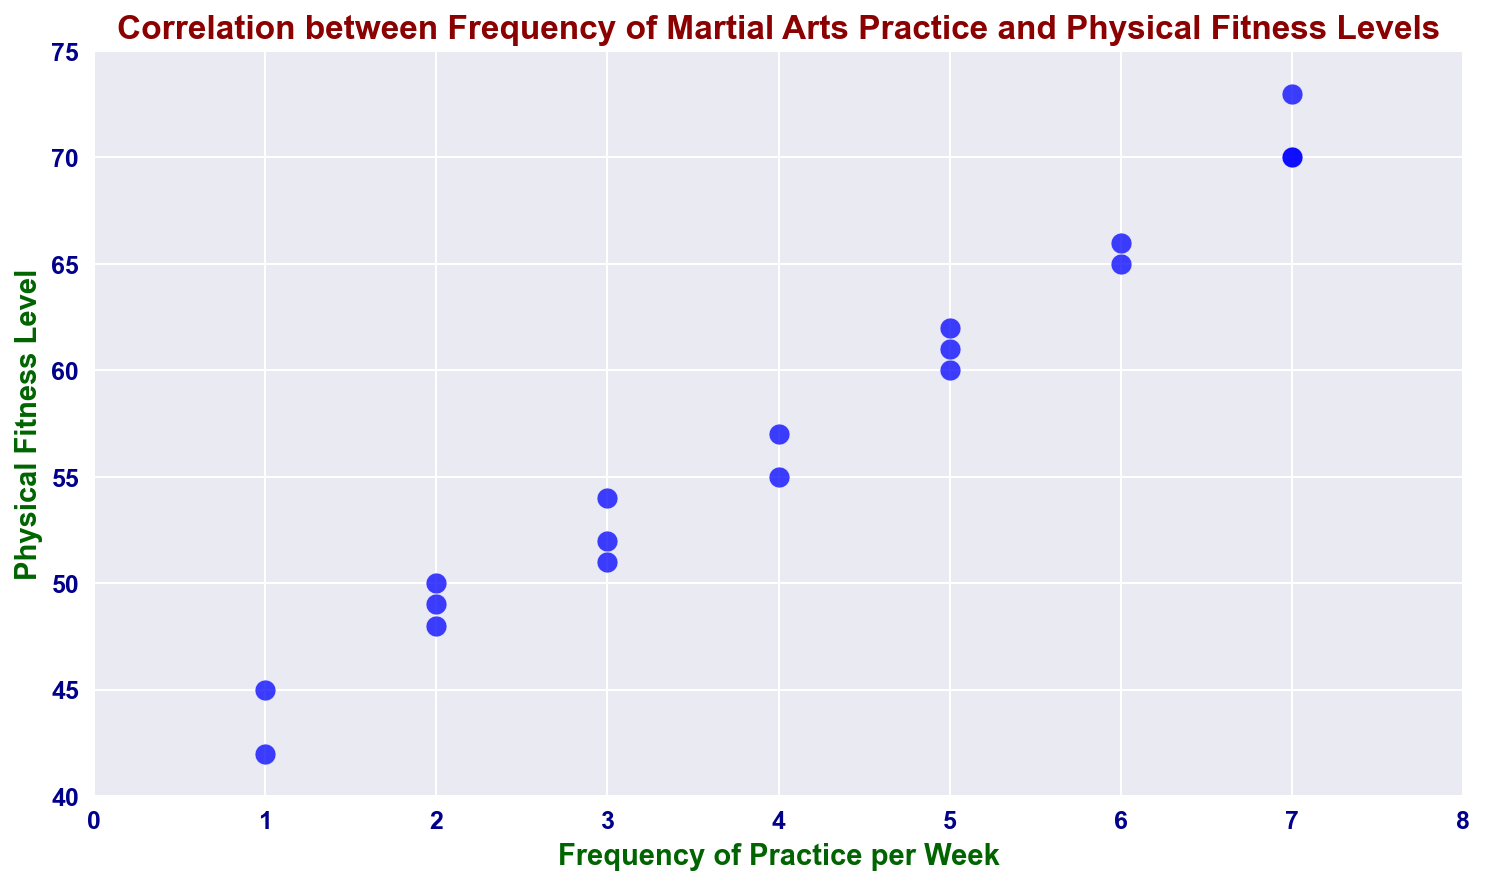What's the highest physical fitness level recorded in the dataset? The highest point on the y-axis (Physical Fitness Level) represents the maximum value. From the scatter plot, the highest y-value is at 73.
Answer: 73 Is there any instance where the physical fitness level is 60? Look for markers positioned at the y-axis value of 60. There is one blue dot that aligns with the value of 60.
Answer: Yes How many data points correspond to a frequency of practice of 7 days per week? Check the x-axis value of 7 and count the number of markers that align vertically with it. There are three blue dots on the x=7 line.
Answer: 3 What's the average physical fitness level for a frequency of 5 days per week? Identify the y-values associated with x=5 (60, 61, and 62). Sum them up (60 + 61 + 62 = 183), and divide by the number of points (3).
Answer: 61 Is there a trend between the frequency of martial arts practice and physical fitness levels? The direction and density of the blue dots on the scatter plot show that as the frequency of practice increases (x-axis), the physical fitness level (y-axis) generally also increases.
Answer: Yes, positive correlation Which frequency of practice per week has the lowest recorded physical fitness level? Identify the y-values for each x-value and find the minimum y-value (42 and 45) which occur at x=1 (1 day per week).
Answer: 1 Are there any outliers in the data? Look for points that deviate significantly from the general trend. There don't appear to be any dots that unusually stand out far from the main cluster.
Answer: No How does the physical fitness level for practicing 3 days per week compare to practicing 4 days per week? Identify the y-values for x=3 (52, 54, and 51) and x=4 (55 and 57). The average for 3 days is (52+54+51)/3 ≈ 52.3, and for 4 days is (55+57)/2 = 56.
Answer: 4 days per week is higher 